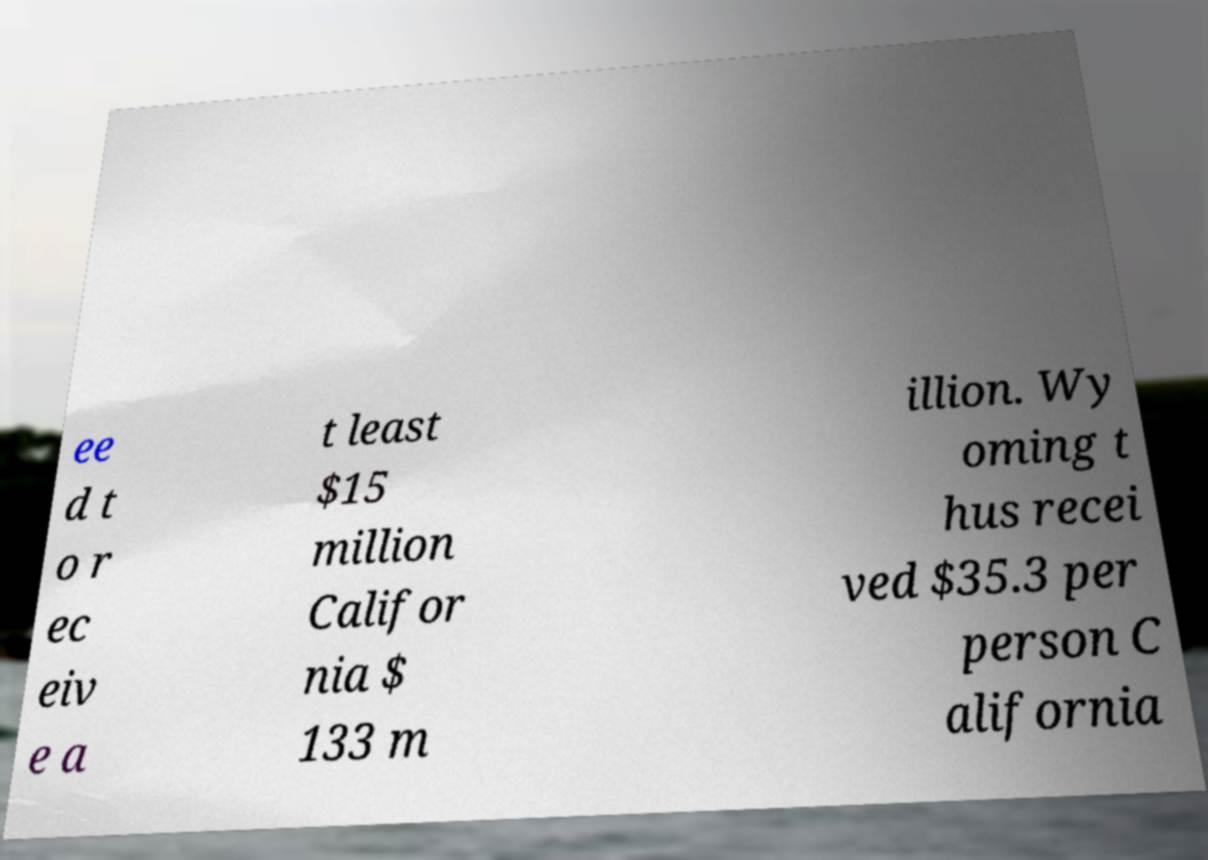There's text embedded in this image that I need extracted. Can you transcribe it verbatim? ee d t o r ec eiv e a t least $15 million Califor nia $ 133 m illion. Wy oming t hus recei ved $35.3 per person C alifornia 